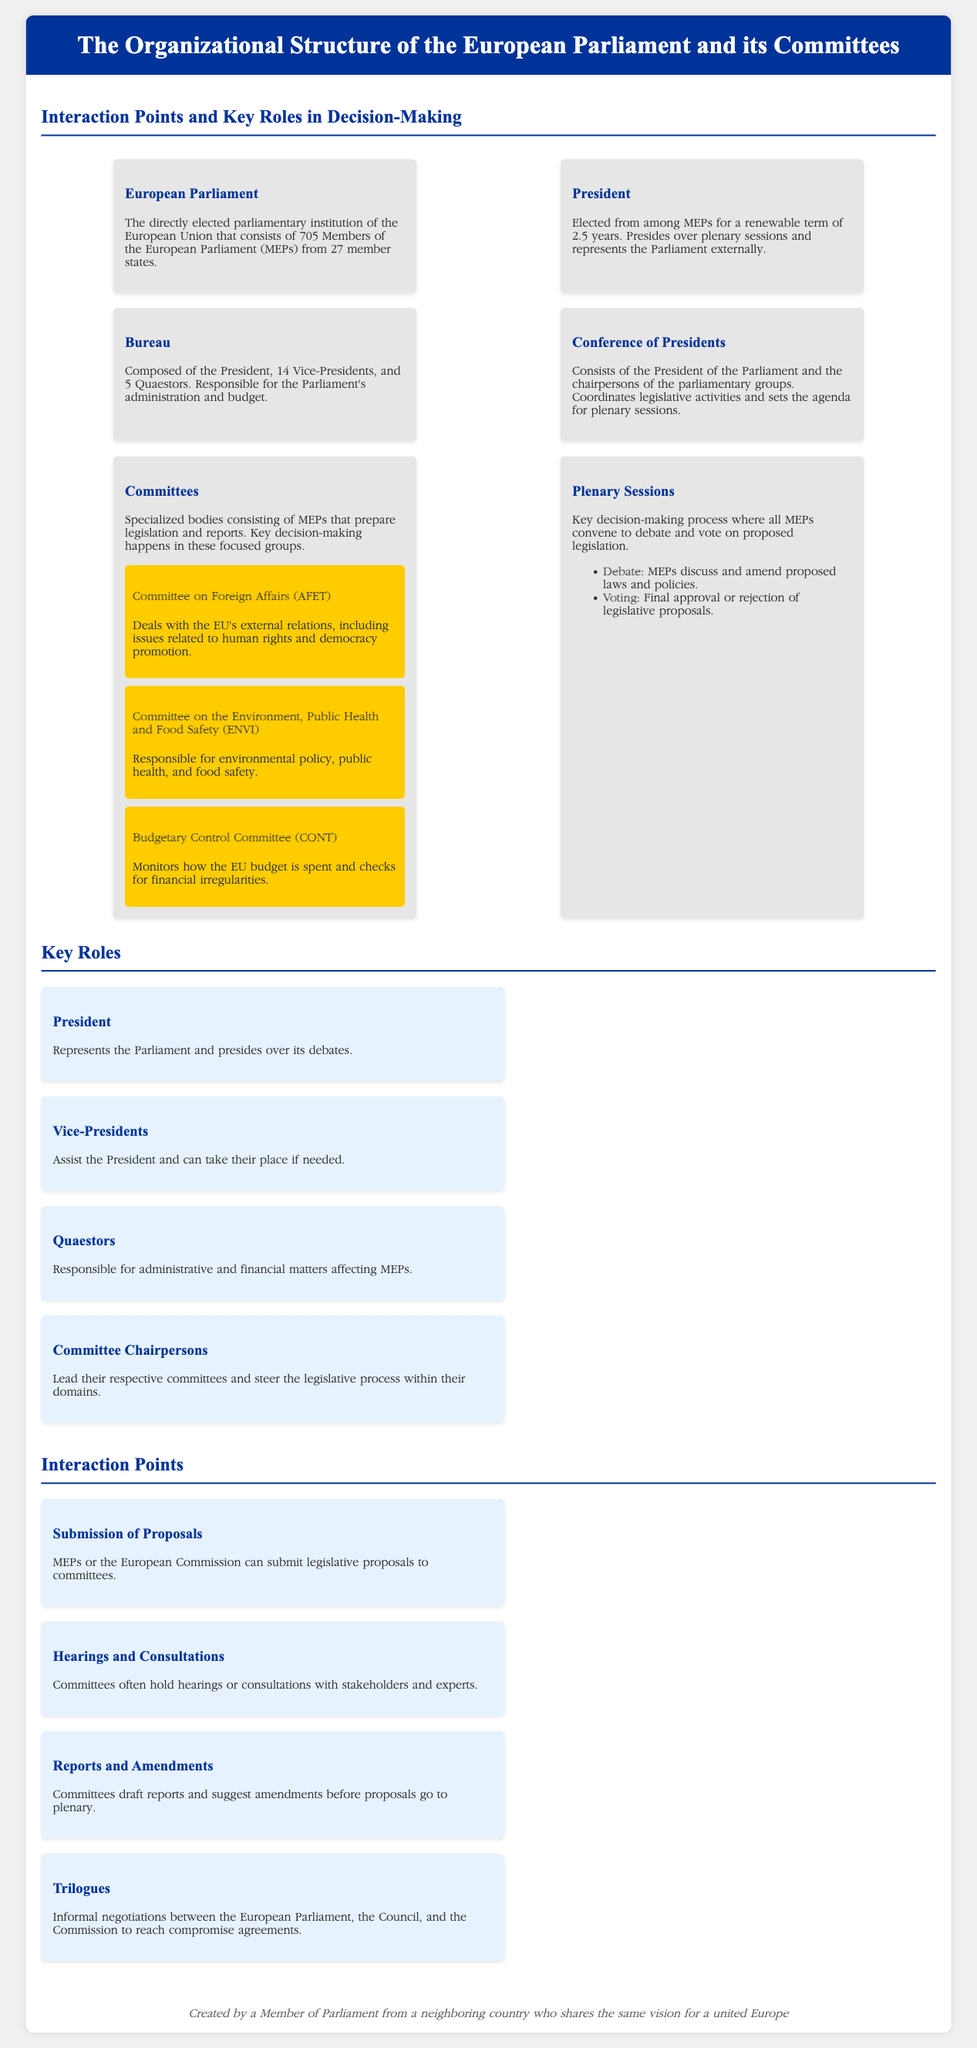What is the total number of Members of the European Parliament? The total number of Members of the European Parliament is specified in the document as 705.
Answer: 705 Who leads the Conference of Presidents? The leader of the Conference of Presidents is the President of the Parliament, as mentioned in the document.
Answer: President of the Parliament How many Vice-Presidents are part of the Bureau? The Bureau is composed of 14 Vice-Presidents, as stated in the document.
Answer: 14 What does the Committee on Foreign Affairs (AFET) deal with? The document specifies that the Committee on Foreign Affairs deals with EU's external relations, including issues related to human rights and democracy promotion.
Answer: EU's external relations What is a trilogue? A trilogue is defined in the document as informal negotiations between the European Parliament, the Council, and the Commission to reach compromise agreements.
Answer: Informal negotiations What is the primary role of Committee Chairpersons? The document explains that Committee Chairpersons lead their respective committees and steer the legislative process within their domains.
Answer: Lead and steer legislative process Which committee is responsible for monitoring the EU budget? The document states that the Budgetary Control Committee monitors how the EU budget is spent.
Answer: Budgetary Control Committee What is the term length for the President of the European Parliament? The document indicates that the President is elected for a renewable term of 2.5 years.
Answer: 2.5 years 